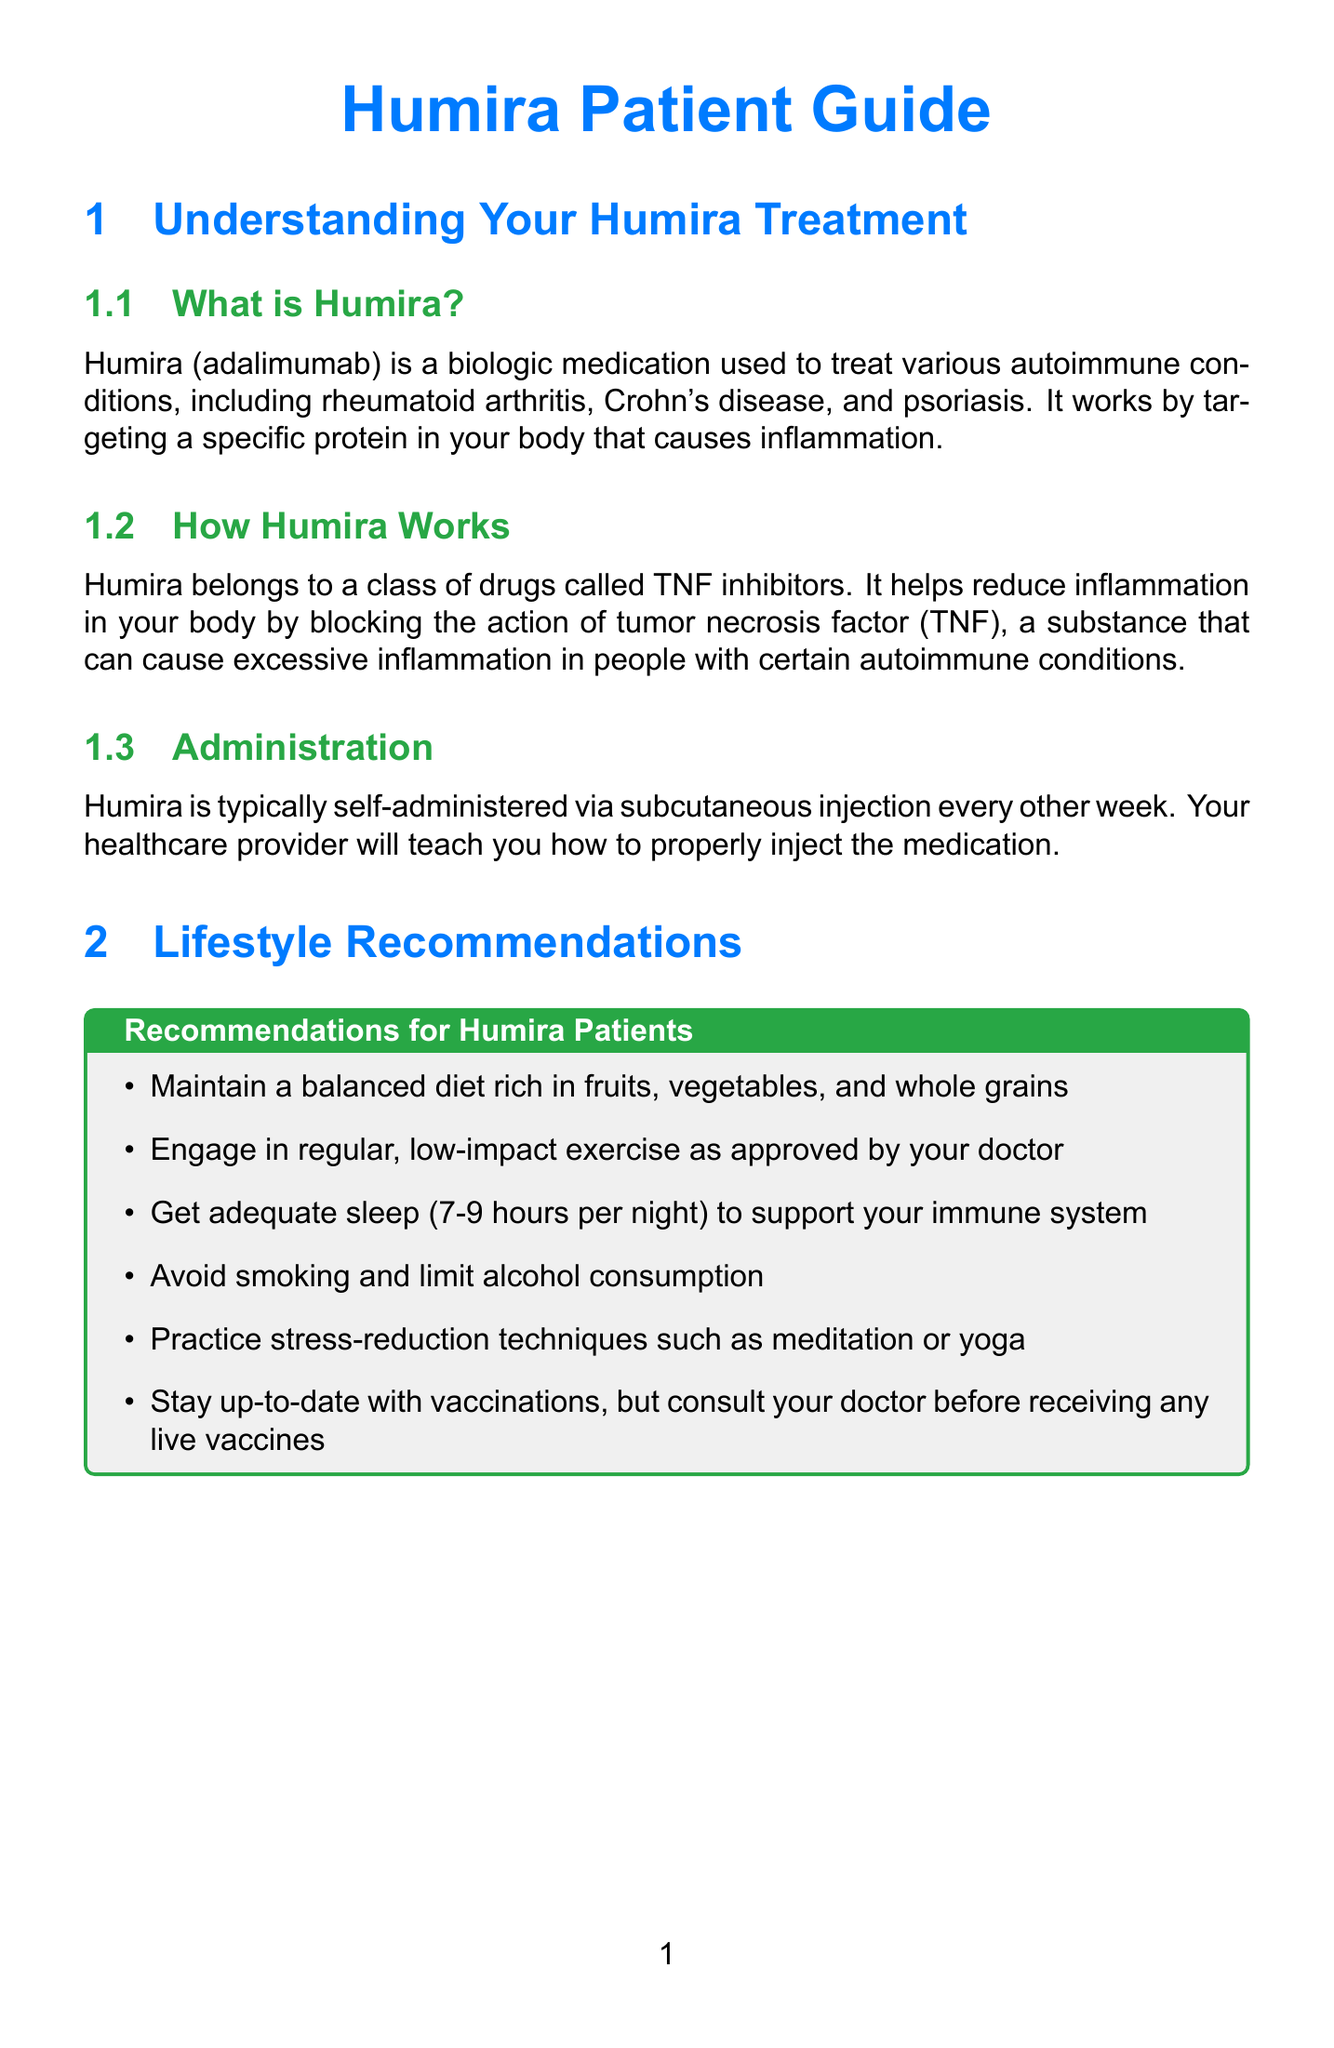What is Humira? Humira is a biologic medication used to treat various autoimmune conditions, which targets a specific protein causing inflammation.
Answer: a biologic medication How often is Humira administered? Humira is typically self-administered via subcutaneous injection every other week.
Answer: every other week Name a lifestyle recommendation for Humira patients. The document lists several lifestyle recommendations, including maintaining a balanced diet rich in fruits, vegetables, and whole grains.
Answer: maintain a balanced diet What should a patient do if they miss a dose of Humira? The document advises to take it as soon as remembered and then continue with the regular schedule, without doubling up.
Answer: take it as soon as remembered Can live vaccines be taken while on Humira? The document states that live vaccines should be avoided while taking Humira, as they may increase the risk of infection.
Answer: no What is a suggested adherence strategy for Humira treatment? One strategy mentioned is to use a medication reminder app like Medisafe or MyTherapy.
Answer: use a medication reminder app List one common side effect of Humira. The document includes injection site reactions, upper respiratory infections, headache, rash, and nausea as common side effects.
Answer: injection site reactions What serious side effect requires immediate medical attention? The document mentions serious infections, allergic reactions, and others as serious side effects that need immediate attention.
Answer: serious infections 